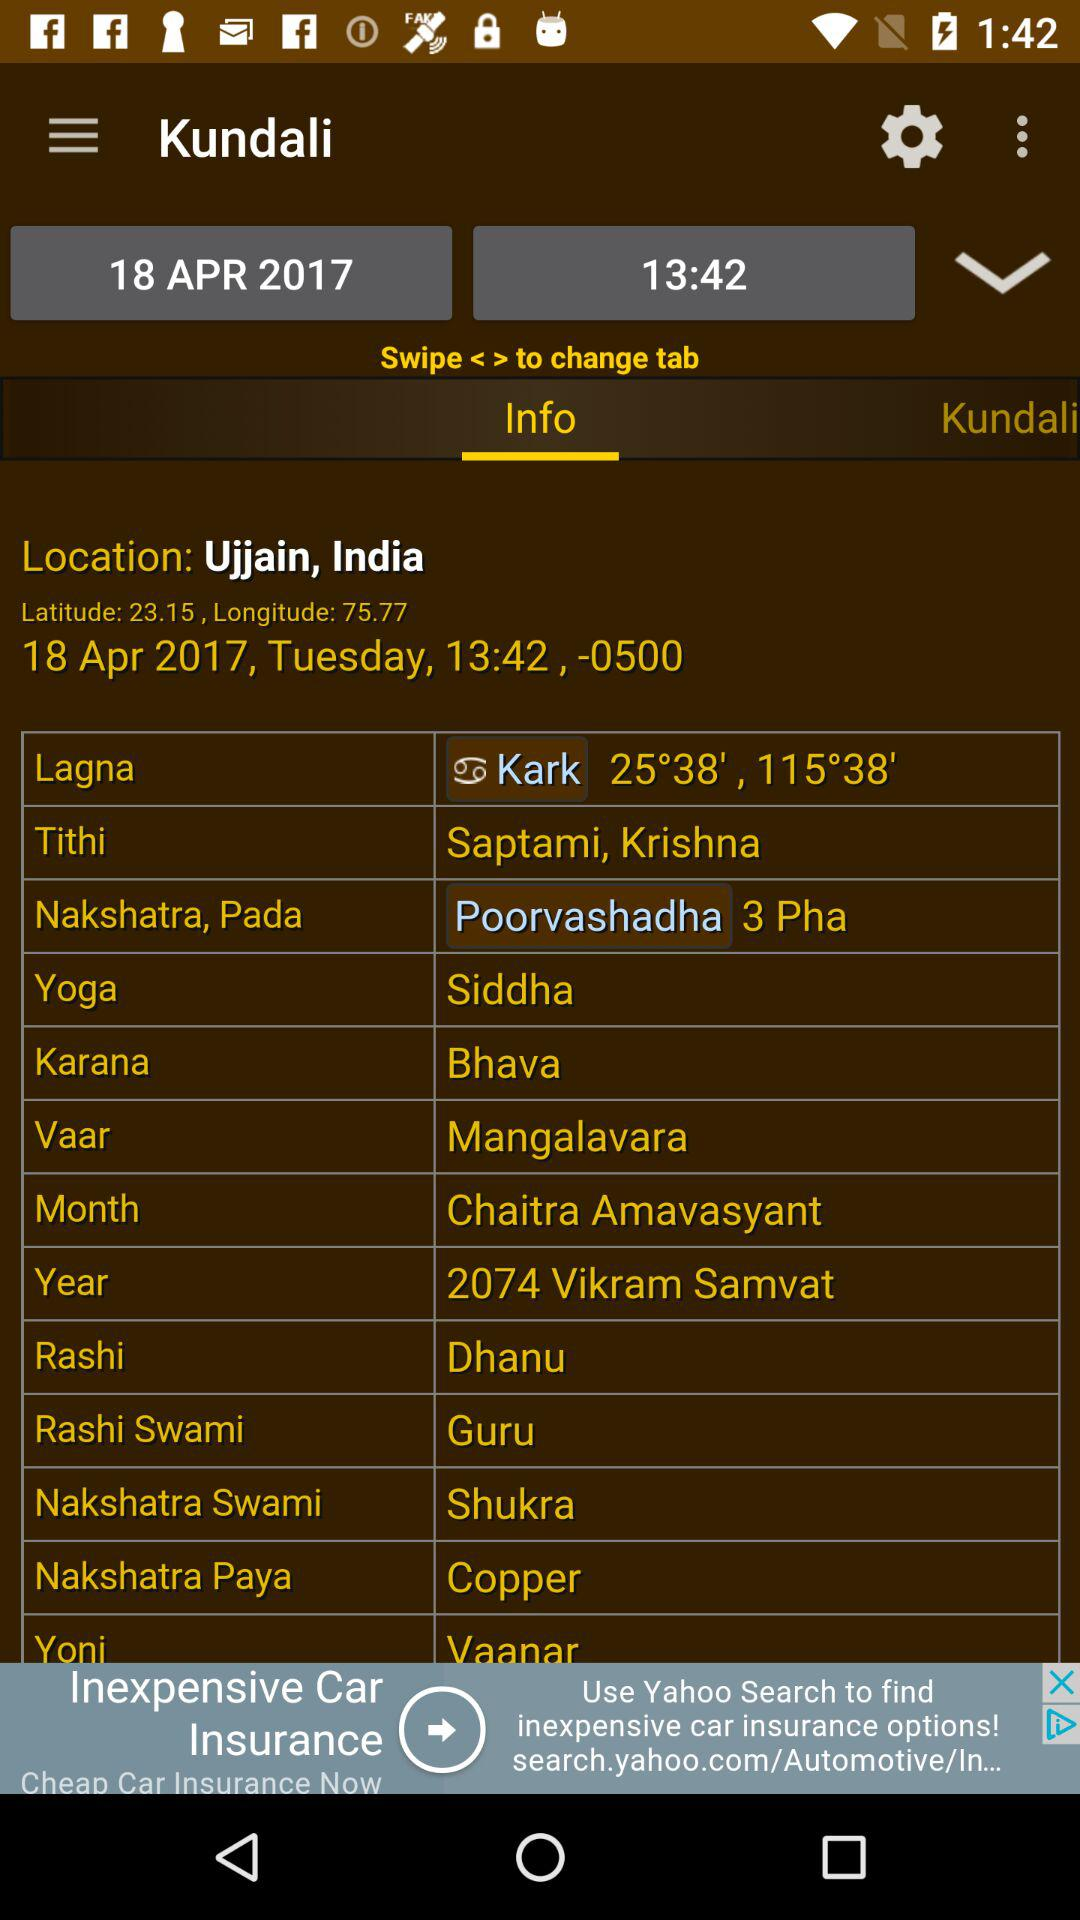What is the name of the Vaar? The name of the Vaar is Mangalavara. 